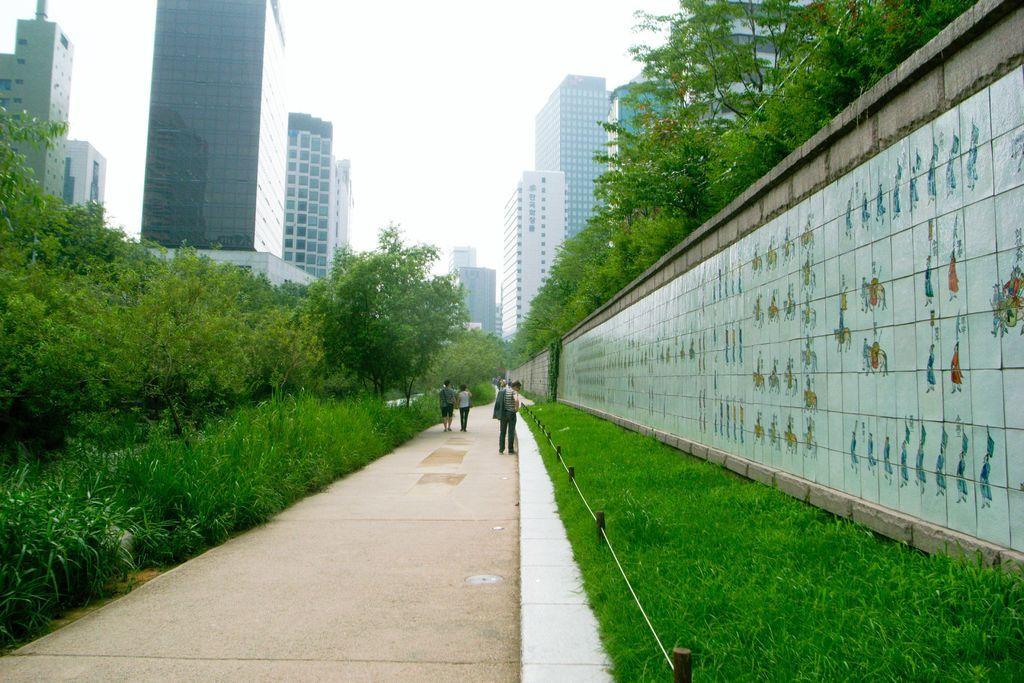Please provide a concise description of this image. In this picture there is a man who is wearing jacket t-shirt, trouser and shoe. He is standing near to the grass. Here we can see two persons walking on the street. On the right there is a wall. In the background we can see many buildings. On the top we can see sky and clouds. On the left we can see trees, plants and grass. 